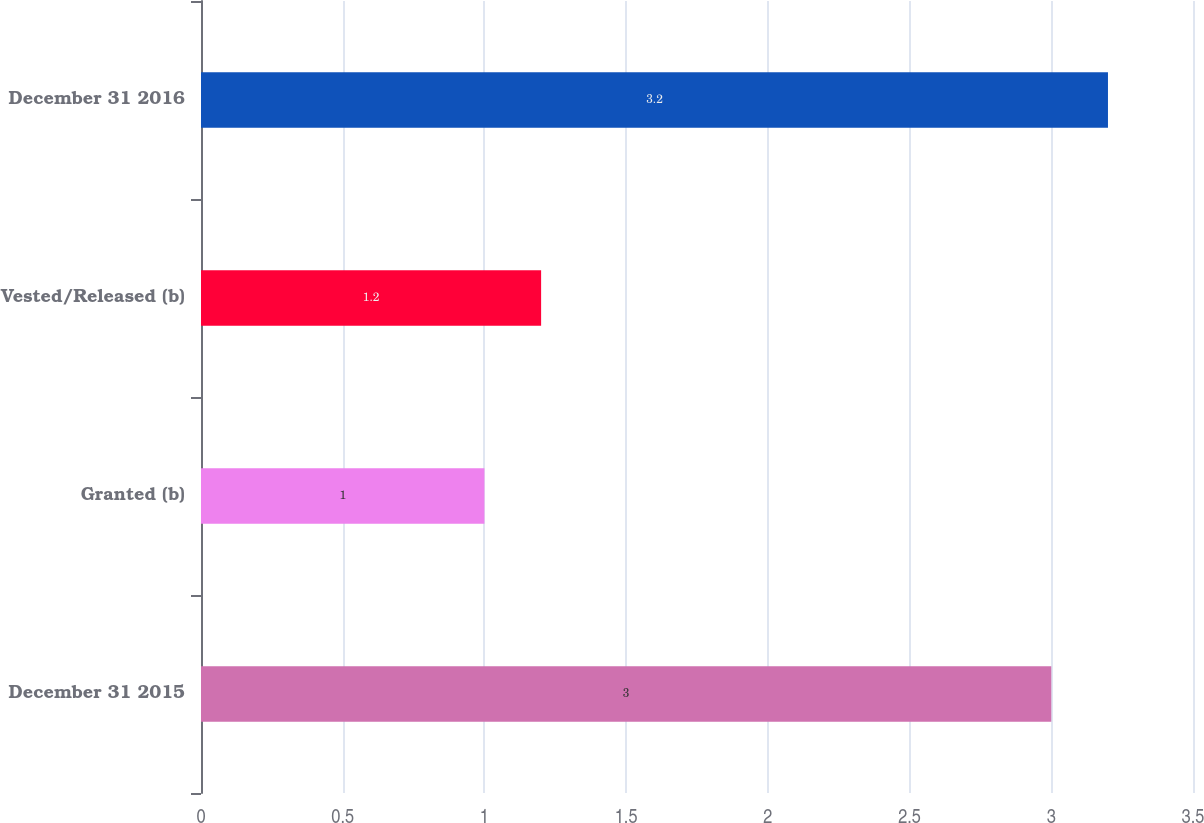<chart> <loc_0><loc_0><loc_500><loc_500><bar_chart><fcel>December 31 2015<fcel>Granted (b)<fcel>Vested/Released (b)<fcel>December 31 2016<nl><fcel>3<fcel>1<fcel>1.2<fcel>3.2<nl></chart> 